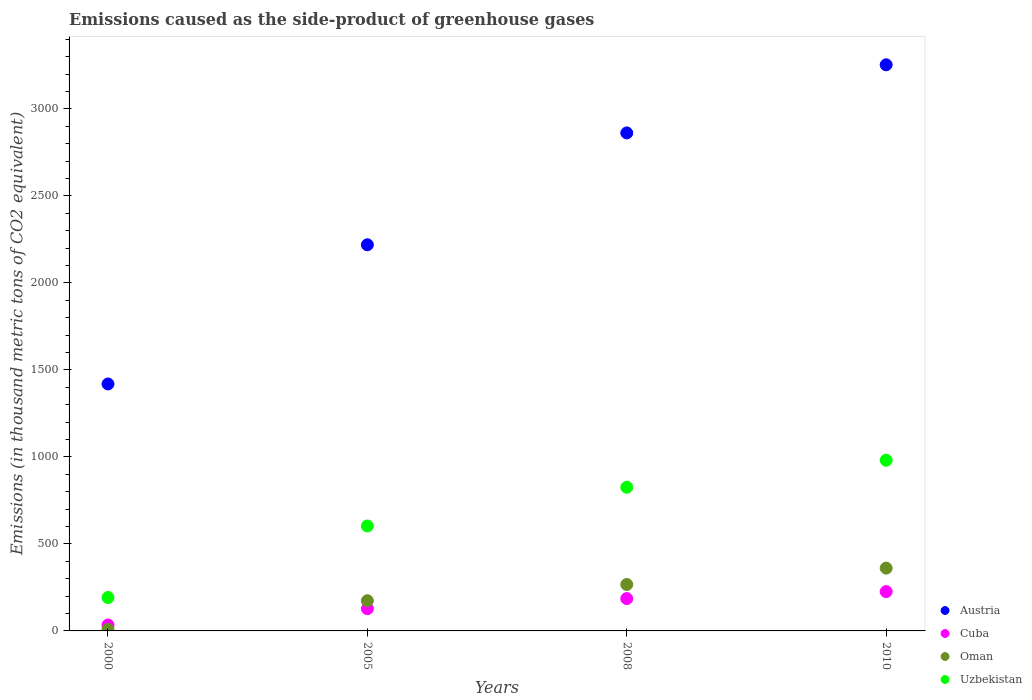How many different coloured dotlines are there?
Provide a succinct answer. 4. What is the emissions caused as the side-product of greenhouse gases in Austria in 2010?
Offer a very short reply. 3254. Across all years, what is the maximum emissions caused as the side-product of greenhouse gases in Austria?
Ensure brevity in your answer.  3254. Across all years, what is the minimum emissions caused as the side-product of greenhouse gases in Cuba?
Offer a terse response. 34.2. In which year was the emissions caused as the side-product of greenhouse gases in Austria maximum?
Offer a very short reply. 2010. What is the total emissions caused as the side-product of greenhouse gases in Oman in the graph?
Provide a short and direct response. 810.1. What is the difference between the emissions caused as the side-product of greenhouse gases in Uzbekistan in 2008 and that in 2010?
Give a very brief answer. -155.4. What is the difference between the emissions caused as the side-product of greenhouse gases in Uzbekistan in 2000 and the emissions caused as the side-product of greenhouse gases in Cuba in 2010?
Give a very brief answer. -34. What is the average emissions caused as the side-product of greenhouse gases in Austria per year?
Ensure brevity in your answer.  2438.85. In the year 2008, what is the difference between the emissions caused as the side-product of greenhouse gases in Cuba and emissions caused as the side-product of greenhouse gases in Oman?
Offer a very short reply. -81. In how many years, is the emissions caused as the side-product of greenhouse gases in Cuba greater than 300 thousand metric tons?
Make the answer very short. 0. What is the ratio of the emissions caused as the side-product of greenhouse gases in Cuba in 2008 to that in 2010?
Offer a very short reply. 0.82. What is the difference between the highest and the second highest emissions caused as the side-product of greenhouse gases in Cuba?
Your response must be concise. 40.1. What is the difference between the highest and the lowest emissions caused as the side-product of greenhouse gases in Austria?
Keep it short and to the point. 1834.5. Is it the case that in every year, the sum of the emissions caused as the side-product of greenhouse gases in Oman and emissions caused as the side-product of greenhouse gases in Uzbekistan  is greater than the emissions caused as the side-product of greenhouse gases in Austria?
Ensure brevity in your answer.  No. Is the emissions caused as the side-product of greenhouse gases in Austria strictly greater than the emissions caused as the side-product of greenhouse gases in Cuba over the years?
Keep it short and to the point. Yes. How many dotlines are there?
Offer a terse response. 4. What is the difference between two consecutive major ticks on the Y-axis?
Provide a succinct answer. 500. Are the values on the major ticks of Y-axis written in scientific E-notation?
Give a very brief answer. No. Does the graph contain grids?
Provide a succinct answer. No. Where does the legend appear in the graph?
Keep it short and to the point. Bottom right. How many legend labels are there?
Your answer should be very brief. 4. What is the title of the graph?
Ensure brevity in your answer.  Emissions caused as the side-product of greenhouse gases. What is the label or title of the X-axis?
Make the answer very short. Years. What is the label or title of the Y-axis?
Your answer should be very brief. Emissions (in thousand metric tons of CO2 equivalent). What is the Emissions (in thousand metric tons of CO2 equivalent) of Austria in 2000?
Your answer should be compact. 1419.5. What is the Emissions (in thousand metric tons of CO2 equivalent) in Cuba in 2000?
Keep it short and to the point. 34.2. What is the Emissions (in thousand metric tons of CO2 equivalent) in Uzbekistan in 2000?
Give a very brief answer. 192. What is the Emissions (in thousand metric tons of CO2 equivalent) in Austria in 2005?
Give a very brief answer. 2219.5. What is the Emissions (in thousand metric tons of CO2 equivalent) of Cuba in 2005?
Your response must be concise. 127.8. What is the Emissions (in thousand metric tons of CO2 equivalent) of Oman in 2005?
Your response must be concise. 173.6. What is the Emissions (in thousand metric tons of CO2 equivalent) in Uzbekistan in 2005?
Ensure brevity in your answer.  603.2. What is the Emissions (in thousand metric tons of CO2 equivalent) in Austria in 2008?
Ensure brevity in your answer.  2862.4. What is the Emissions (in thousand metric tons of CO2 equivalent) of Cuba in 2008?
Provide a succinct answer. 185.9. What is the Emissions (in thousand metric tons of CO2 equivalent) of Oman in 2008?
Keep it short and to the point. 266.9. What is the Emissions (in thousand metric tons of CO2 equivalent) in Uzbekistan in 2008?
Provide a short and direct response. 825.6. What is the Emissions (in thousand metric tons of CO2 equivalent) in Austria in 2010?
Keep it short and to the point. 3254. What is the Emissions (in thousand metric tons of CO2 equivalent) in Cuba in 2010?
Your response must be concise. 226. What is the Emissions (in thousand metric tons of CO2 equivalent) in Oman in 2010?
Ensure brevity in your answer.  361. What is the Emissions (in thousand metric tons of CO2 equivalent) in Uzbekistan in 2010?
Your answer should be very brief. 981. Across all years, what is the maximum Emissions (in thousand metric tons of CO2 equivalent) of Austria?
Offer a terse response. 3254. Across all years, what is the maximum Emissions (in thousand metric tons of CO2 equivalent) of Cuba?
Offer a very short reply. 226. Across all years, what is the maximum Emissions (in thousand metric tons of CO2 equivalent) in Oman?
Keep it short and to the point. 361. Across all years, what is the maximum Emissions (in thousand metric tons of CO2 equivalent) in Uzbekistan?
Keep it short and to the point. 981. Across all years, what is the minimum Emissions (in thousand metric tons of CO2 equivalent) of Austria?
Your answer should be very brief. 1419.5. Across all years, what is the minimum Emissions (in thousand metric tons of CO2 equivalent) in Cuba?
Your answer should be compact. 34.2. Across all years, what is the minimum Emissions (in thousand metric tons of CO2 equivalent) of Uzbekistan?
Offer a terse response. 192. What is the total Emissions (in thousand metric tons of CO2 equivalent) of Austria in the graph?
Offer a very short reply. 9755.4. What is the total Emissions (in thousand metric tons of CO2 equivalent) of Cuba in the graph?
Make the answer very short. 573.9. What is the total Emissions (in thousand metric tons of CO2 equivalent) in Oman in the graph?
Provide a succinct answer. 810.1. What is the total Emissions (in thousand metric tons of CO2 equivalent) of Uzbekistan in the graph?
Provide a succinct answer. 2601.8. What is the difference between the Emissions (in thousand metric tons of CO2 equivalent) in Austria in 2000 and that in 2005?
Make the answer very short. -800. What is the difference between the Emissions (in thousand metric tons of CO2 equivalent) in Cuba in 2000 and that in 2005?
Offer a very short reply. -93.6. What is the difference between the Emissions (in thousand metric tons of CO2 equivalent) of Oman in 2000 and that in 2005?
Ensure brevity in your answer.  -165. What is the difference between the Emissions (in thousand metric tons of CO2 equivalent) in Uzbekistan in 2000 and that in 2005?
Offer a very short reply. -411.2. What is the difference between the Emissions (in thousand metric tons of CO2 equivalent) in Austria in 2000 and that in 2008?
Ensure brevity in your answer.  -1442.9. What is the difference between the Emissions (in thousand metric tons of CO2 equivalent) of Cuba in 2000 and that in 2008?
Your answer should be compact. -151.7. What is the difference between the Emissions (in thousand metric tons of CO2 equivalent) in Oman in 2000 and that in 2008?
Provide a short and direct response. -258.3. What is the difference between the Emissions (in thousand metric tons of CO2 equivalent) in Uzbekistan in 2000 and that in 2008?
Offer a terse response. -633.6. What is the difference between the Emissions (in thousand metric tons of CO2 equivalent) in Austria in 2000 and that in 2010?
Provide a succinct answer. -1834.5. What is the difference between the Emissions (in thousand metric tons of CO2 equivalent) in Cuba in 2000 and that in 2010?
Ensure brevity in your answer.  -191.8. What is the difference between the Emissions (in thousand metric tons of CO2 equivalent) in Oman in 2000 and that in 2010?
Offer a very short reply. -352.4. What is the difference between the Emissions (in thousand metric tons of CO2 equivalent) in Uzbekistan in 2000 and that in 2010?
Keep it short and to the point. -789. What is the difference between the Emissions (in thousand metric tons of CO2 equivalent) in Austria in 2005 and that in 2008?
Your answer should be compact. -642.9. What is the difference between the Emissions (in thousand metric tons of CO2 equivalent) in Cuba in 2005 and that in 2008?
Your response must be concise. -58.1. What is the difference between the Emissions (in thousand metric tons of CO2 equivalent) in Oman in 2005 and that in 2008?
Keep it short and to the point. -93.3. What is the difference between the Emissions (in thousand metric tons of CO2 equivalent) in Uzbekistan in 2005 and that in 2008?
Provide a short and direct response. -222.4. What is the difference between the Emissions (in thousand metric tons of CO2 equivalent) in Austria in 2005 and that in 2010?
Provide a short and direct response. -1034.5. What is the difference between the Emissions (in thousand metric tons of CO2 equivalent) of Cuba in 2005 and that in 2010?
Provide a succinct answer. -98.2. What is the difference between the Emissions (in thousand metric tons of CO2 equivalent) of Oman in 2005 and that in 2010?
Make the answer very short. -187.4. What is the difference between the Emissions (in thousand metric tons of CO2 equivalent) in Uzbekistan in 2005 and that in 2010?
Your response must be concise. -377.8. What is the difference between the Emissions (in thousand metric tons of CO2 equivalent) of Austria in 2008 and that in 2010?
Ensure brevity in your answer.  -391.6. What is the difference between the Emissions (in thousand metric tons of CO2 equivalent) of Cuba in 2008 and that in 2010?
Your answer should be very brief. -40.1. What is the difference between the Emissions (in thousand metric tons of CO2 equivalent) in Oman in 2008 and that in 2010?
Provide a succinct answer. -94.1. What is the difference between the Emissions (in thousand metric tons of CO2 equivalent) of Uzbekistan in 2008 and that in 2010?
Provide a succinct answer. -155.4. What is the difference between the Emissions (in thousand metric tons of CO2 equivalent) of Austria in 2000 and the Emissions (in thousand metric tons of CO2 equivalent) of Cuba in 2005?
Offer a terse response. 1291.7. What is the difference between the Emissions (in thousand metric tons of CO2 equivalent) of Austria in 2000 and the Emissions (in thousand metric tons of CO2 equivalent) of Oman in 2005?
Keep it short and to the point. 1245.9. What is the difference between the Emissions (in thousand metric tons of CO2 equivalent) in Austria in 2000 and the Emissions (in thousand metric tons of CO2 equivalent) in Uzbekistan in 2005?
Provide a succinct answer. 816.3. What is the difference between the Emissions (in thousand metric tons of CO2 equivalent) of Cuba in 2000 and the Emissions (in thousand metric tons of CO2 equivalent) of Oman in 2005?
Keep it short and to the point. -139.4. What is the difference between the Emissions (in thousand metric tons of CO2 equivalent) in Cuba in 2000 and the Emissions (in thousand metric tons of CO2 equivalent) in Uzbekistan in 2005?
Provide a succinct answer. -569. What is the difference between the Emissions (in thousand metric tons of CO2 equivalent) of Oman in 2000 and the Emissions (in thousand metric tons of CO2 equivalent) of Uzbekistan in 2005?
Offer a terse response. -594.6. What is the difference between the Emissions (in thousand metric tons of CO2 equivalent) of Austria in 2000 and the Emissions (in thousand metric tons of CO2 equivalent) of Cuba in 2008?
Give a very brief answer. 1233.6. What is the difference between the Emissions (in thousand metric tons of CO2 equivalent) of Austria in 2000 and the Emissions (in thousand metric tons of CO2 equivalent) of Oman in 2008?
Give a very brief answer. 1152.6. What is the difference between the Emissions (in thousand metric tons of CO2 equivalent) of Austria in 2000 and the Emissions (in thousand metric tons of CO2 equivalent) of Uzbekistan in 2008?
Offer a terse response. 593.9. What is the difference between the Emissions (in thousand metric tons of CO2 equivalent) of Cuba in 2000 and the Emissions (in thousand metric tons of CO2 equivalent) of Oman in 2008?
Your answer should be compact. -232.7. What is the difference between the Emissions (in thousand metric tons of CO2 equivalent) in Cuba in 2000 and the Emissions (in thousand metric tons of CO2 equivalent) in Uzbekistan in 2008?
Provide a short and direct response. -791.4. What is the difference between the Emissions (in thousand metric tons of CO2 equivalent) in Oman in 2000 and the Emissions (in thousand metric tons of CO2 equivalent) in Uzbekistan in 2008?
Ensure brevity in your answer.  -817. What is the difference between the Emissions (in thousand metric tons of CO2 equivalent) in Austria in 2000 and the Emissions (in thousand metric tons of CO2 equivalent) in Cuba in 2010?
Make the answer very short. 1193.5. What is the difference between the Emissions (in thousand metric tons of CO2 equivalent) of Austria in 2000 and the Emissions (in thousand metric tons of CO2 equivalent) of Oman in 2010?
Your answer should be very brief. 1058.5. What is the difference between the Emissions (in thousand metric tons of CO2 equivalent) of Austria in 2000 and the Emissions (in thousand metric tons of CO2 equivalent) of Uzbekistan in 2010?
Keep it short and to the point. 438.5. What is the difference between the Emissions (in thousand metric tons of CO2 equivalent) of Cuba in 2000 and the Emissions (in thousand metric tons of CO2 equivalent) of Oman in 2010?
Keep it short and to the point. -326.8. What is the difference between the Emissions (in thousand metric tons of CO2 equivalent) in Cuba in 2000 and the Emissions (in thousand metric tons of CO2 equivalent) in Uzbekistan in 2010?
Keep it short and to the point. -946.8. What is the difference between the Emissions (in thousand metric tons of CO2 equivalent) of Oman in 2000 and the Emissions (in thousand metric tons of CO2 equivalent) of Uzbekistan in 2010?
Your response must be concise. -972.4. What is the difference between the Emissions (in thousand metric tons of CO2 equivalent) in Austria in 2005 and the Emissions (in thousand metric tons of CO2 equivalent) in Cuba in 2008?
Offer a terse response. 2033.6. What is the difference between the Emissions (in thousand metric tons of CO2 equivalent) of Austria in 2005 and the Emissions (in thousand metric tons of CO2 equivalent) of Oman in 2008?
Keep it short and to the point. 1952.6. What is the difference between the Emissions (in thousand metric tons of CO2 equivalent) in Austria in 2005 and the Emissions (in thousand metric tons of CO2 equivalent) in Uzbekistan in 2008?
Offer a very short reply. 1393.9. What is the difference between the Emissions (in thousand metric tons of CO2 equivalent) of Cuba in 2005 and the Emissions (in thousand metric tons of CO2 equivalent) of Oman in 2008?
Provide a short and direct response. -139.1. What is the difference between the Emissions (in thousand metric tons of CO2 equivalent) in Cuba in 2005 and the Emissions (in thousand metric tons of CO2 equivalent) in Uzbekistan in 2008?
Your response must be concise. -697.8. What is the difference between the Emissions (in thousand metric tons of CO2 equivalent) in Oman in 2005 and the Emissions (in thousand metric tons of CO2 equivalent) in Uzbekistan in 2008?
Provide a succinct answer. -652. What is the difference between the Emissions (in thousand metric tons of CO2 equivalent) in Austria in 2005 and the Emissions (in thousand metric tons of CO2 equivalent) in Cuba in 2010?
Offer a terse response. 1993.5. What is the difference between the Emissions (in thousand metric tons of CO2 equivalent) of Austria in 2005 and the Emissions (in thousand metric tons of CO2 equivalent) of Oman in 2010?
Provide a short and direct response. 1858.5. What is the difference between the Emissions (in thousand metric tons of CO2 equivalent) in Austria in 2005 and the Emissions (in thousand metric tons of CO2 equivalent) in Uzbekistan in 2010?
Offer a terse response. 1238.5. What is the difference between the Emissions (in thousand metric tons of CO2 equivalent) of Cuba in 2005 and the Emissions (in thousand metric tons of CO2 equivalent) of Oman in 2010?
Offer a terse response. -233.2. What is the difference between the Emissions (in thousand metric tons of CO2 equivalent) in Cuba in 2005 and the Emissions (in thousand metric tons of CO2 equivalent) in Uzbekistan in 2010?
Provide a succinct answer. -853.2. What is the difference between the Emissions (in thousand metric tons of CO2 equivalent) in Oman in 2005 and the Emissions (in thousand metric tons of CO2 equivalent) in Uzbekistan in 2010?
Give a very brief answer. -807.4. What is the difference between the Emissions (in thousand metric tons of CO2 equivalent) in Austria in 2008 and the Emissions (in thousand metric tons of CO2 equivalent) in Cuba in 2010?
Your answer should be very brief. 2636.4. What is the difference between the Emissions (in thousand metric tons of CO2 equivalent) in Austria in 2008 and the Emissions (in thousand metric tons of CO2 equivalent) in Oman in 2010?
Your response must be concise. 2501.4. What is the difference between the Emissions (in thousand metric tons of CO2 equivalent) in Austria in 2008 and the Emissions (in thousand metric tons of CO2 equivalent) in Uzbekistan in 2010?
Keep it short and to the point. 1881.4. What is the difference between the Emissions (in thousand metric tons of CO2 equivalent) of Cuba in 2008 and the Emissions (in thousand metric tons of CO2 equivalent) of Oman in 2010?
Make the answer very short. -175.1. What is the difference between the Emissions (in thousand metric tons of CO2 equivalent) in Cuba in 2008 and the Emissions (in thousand metric tons of CO2 equivalent) in Uzbekistan in 2010?
Your response must be concise. -795.1. What is the difference between the Emissions (in thousand metric tons of CO2 equivalent) of Oman in 2008 and the Emissions (in thousand metric tons of CO2 equivalent) of Uzbekistan in 2010?
Make the answer very short. -714.1. What is the average Emissions (in thousand metric tons of CO2 equivalent) of Austria per year?
Your answer should be compact. 2438.85. What is the average Emissions (in thousand metric tons of CO2 equivalent) of Cuba per year?
Your answer should be very brief. 143.47. What is the average Emissions (in thousand metric tons of CO2 equivalent) of Oman per year?
Keep it short and to the point. 202.53. What is the average Emissions (in thousand metric tons of CO2 equivalent) of Uzbekistan per year?
Offer a very short reply. 650.45. In the year 2000, what is the difference between the Emissions (in thousand metric tons of CO2 equivalent) of Austria and Emissions (in thousand metric tons of CO2 equivalent) of Cuba?
Your answer should be very brief. 1385.3. In the year 2000, what is the difference between the Emissions (in thousand metric tons of CO2 equivalent) in Austria and Emissions (in thousand metric tons of CO2 equivalent) in Oman?
Provide a succinct answer. 1410.9. In the year 2000, what is the difference between the Emissions (in thousand metric tons of CO2 equivalent) in Austria and Emissions (in thousand metric tons of CO2 equivalent) in Uzbekistan?
Ensure brevity in your answer.  1227.5. In the year 2000, what is the difference between the Emissions (in thousand metric tons of CO2 equivalent) in Cuba and Emissions (in thousand metric tons of CO2 equivalent) in Oman?
Keep it short and to the point. 25.6. In the year 2000, what is the difference between the Emissions (in thousand metric tons of CO2 equivalent) in Cuba and Emissions (in thousand metric tons of CO2 equivalent) in Uzbekistan?
Give a very brief answer. -157.8. In the year 2000, what is the difference between the Emissions (in thousand metric tons of CO2 equivalent) in Oman and Emissions (in thousand metric tons of CO2 equivalent) in Uzbekistan?
Your response must be concise. -183.4. In the year 2005, what is the difference between the Emissions (in thousand metric tons of CO2 equivalent) of Austria and Emissions (in thousand metric tons of CO2 equivalent) of Cuba?
Your response must be concise. 2091.7. In the year 2005, what is the difference between the Emissions (in thousand metric tons of CO2 equivalent) of Austria and Emissions (in thousand metric tons of CO2 equivalent) of Oman?
Provide a succinct answer. 2045.9. In the year 2005, what is the difference between the Emissions (in thousand metric tons of CO2 equivalent) in Austria and Emissions (in thousand metric tons of CO2 equivalent) in Uzbekistan?
Offer a terse response. 1616.3. In the year 2005, what is the difference between the Emissions (in thousand metric tons of CO2 equivalent) of Cuba and Emissions (in thousand metric tons of CO2 equivalent) of Oman?
Ensure brevity in your answer.  -45.8. In the year 2005, what is the difference between the Emissions (in thousand metric tons of CO2 equivalent) in Cuba and Emissions (in thousand metric tons of CO2 equivalent) in Uzbekistan?
Keep it short and to the point. -475.4. In the year 2005, what is the difference between the Emissions (in thousand metric tons of CO2 equivalent) of Oman and Emissions (in thousand metric tons of CO2 equivalent) of Uzbekistan?
Ensure brevity in your answer.  -429.6. In the year 2008, what is the difference between the Emissions (in thousand metric tons of CO2 equivalent) of Austria and Emissions (in thousand metric tons of CO2 equivalent) of Cuba?
Offer a terse response. 2676.5. In the year 2008, what is the difference between the Emissions (in thousand metric tons of CO2 equivalent) in Austria and Emissions (in thousand metric tons of CO2 equivalent) in Oman?
Offer a very short reply. 2595.5. In the year 2008, what is the difference between the Emissions (in thousand metric tons of CO2 equivalent) in Austria and Emissions (in thousand metric tons of CO2 equivalent) in Uzbekistan?
Your answer should be compact. 2036.8. In the year 2008, what is the difference between the Emissions (in thousand metric tons of CO2 equivalent) of Cuba and Emissions (in thousand metric tons of CO2 equivalent) of Oman?
Your response must be concise. -81. In the year 2008, what is the difference between the Emissions (in thousand metric tons of CO2 equivalent) in Cuba and Emissions (in thousand metric tons of CO2 equivalent) in Uzbekistan?
Offer a very short reply. -639.7. In the year 2008, what is the difference between the Emissions (in thousand metric tons of CO2 equivalent) in Oman and Emissions (in thousand metric tons of CO2 equivalent) in Uzbekistan?
Ensure brevity in your answer.  -558.7. In the year 2010, what is the difference between the Emissions (in thousand metric tons of CO2 equivalent) in Austria and Emissions (in thousand metric tons of CO2 equivalent) in Cuba?
Your answer should be compact. 3028. In the year 2010, what is the difference between the Emissions (in thousand metric tons of CO2 equivalent) of Austria and Emissions (in thousand metric tons of CO2 equivalent) of Oman?
Ensure brevity in your answer.  2893. In the year 2010, what is the difference between the Emissions (in thousand metric tons of CO2 equivalent) in Austria and Emissions (in thousand metric tons of CO2 equivalent) in Uzbekistan?
Offer a very short reply. 2273. In the year 2010, what is the difference between the Emissions (in thousand metric tons of CO2 equivalent) in Cuba and Emissions (in thousand metric tons of CO2 equivalent) in Oman?
Provide a short and direct response. -135. In the year 2010, what is the difference between the Emissions (in thousand metric tons of CO2 equivalent) of Cuba and Emissions (in thousand metric tons of CO2 equivalent) of Uzbekistan?
Give a very brief answer. -755. In the year 2010, what is the difference between the Emissions (in thousand metric tons of CO2 equivalent) in Oman and Emissions (in thousand metric tons of CO2 equivalent) in Uzbekistan?
Make the answer very short. -620. What is the ratio of the Emissions (in thousand metric tons of CO2 equivalent) of Austria in 2000 to that in 2005?
Offer a very short reply. 0.64. What is the ratio of the Emissions (in thousand metric tons of CO2 equivalent) of Cuba in 2000 to that in 2005?
Ensure brevity in your answer.  0.27. What is the ratio of the Emissions (in thousand metric tons of CO2 equivalent) in Oman in 2000 to that in 2005?
Ensure brevity in your answer.  0.05. What is the ratio of the Emissions (in thousand metric tons of CO2 equivalent) of Uzbekistan in 2000 to that in 2005?
Provide a short and direct response. 0.32. What is the ratio of the Emissions (in thousand metric tons of CO2 equivalent) in Austria in 2000 to that in 2008?
Give a very brief answer. 0.5. What is the ratio of the Emissions (in thousand metric tons of CO2 equivalent) in Cuba in 2000 to that in 2008?
Your answer should be very brief. 0.18. What is the ratio of the Emissions (in thousand metric tons of CO2 equivalent) in Oman in 2000 to that in 2008?
Give a very brief answer. 0.03. What is the ratio of the Emissions (in thousand metric tons of CO2 equivalent) of Uzbekistan in 2000 to that in 2008?
Give a very brief answer. 0.23. What is the ratio of the Emissions (in thousand metric tons of CO2 equivalent) of Austria in 2000 to that in 2010?
Offer a terse response. 0.44. What is the ratio of the Emissions (in thousand metric tons of CO2 equivalent) of Cuba in 2000 to that in 2010?
Make the answer very short. 0.15. What is the ratio of the Emissions (in thousand metric tons of CO2 equivalent) of Oman in 2000 to that in 2010?
Give a very brief answer. 0.02. What is the ratio of the Emissions (in thousand metric tons of CO2 equivalent) in Uzbekistan in 2000 to that in 2010?
Your answer should be compact. 0.2. What is the ratio of the Emissions (in thousand metric tons of CO2 equivalent) of Austria in 2005 to that in 2008?
Offer a very short reply. 0.78. What is the ratio of the Emissions (in thousand metric tons of CO2 equivalent) in Cuba in 2005 to that in 2008?
Offer a terse response. 0.69. What is the ratio of the Emissions (in thousand metric tons of CO2 equivalent) in Oman in 2005 to that in 2008?
Offer a very short reply. 0.65. What is the ratio of the Emissions (in thousand metric tons of CO2 equivalent) of Uzbekistan in 2005 to that in 2008?
Your response must be concise. 0.73. What is the ratio of the Emissions (in thousand metric tons of CO2 equivalent) in Austria in 2005 to that in 2010?
Offer a terse response. 0.68. What is the ratio of the Emissions (in thousand metric tons of CO2 equivalent) in Cuba in 2005 to that in 2010?
Provide a short and direct response. 0.57. What is the ratio of the Emissions (in thousand metric tons of CO2 equivalent) in Oman in 2005 to that in 2010?
Offer a terse response. 0.48. What is the ratio of the Emissions (in thousand metric tons of CO2 equivalent) of Uzbekistan in 2005 to that in 2010?
Make the answer very short. 0.61. What is the ratio of the Emissions (in thousand metric tons of CO2 equivalent) of Austria in 2008 to that in 2010?
Your answer should be compact. 0.88. What is the ratio of the Emissions (in thousand metric tons of CO2 equivalent) in Cuba in 2008 to that in 2010?
Offer a very short reply. 0.82. What is the ratio of the Emissions (in thousand metric tons of CO2 equivalent) of Oman in 2008 to that in 2010?
Ensure brevity in your answer.  0.74. What is the ratio of the Emissions (in thousand metric tons of CO2 equivalent) of Uzbekistan in 2008 to that in 2010?
Your answer should be very brief. 0.84. What is the difference between the highest and the second highest Emissions (in thousand metric tons of CO2 equivalent) of Austria?
Offer a very short reply. 391.6. What is the difference between the highest and the second highest Emissions (in thousand metric tons of CO2 equivalent) in Cuba?
Offer a terse response. 40.1. What is the difference between the highest and the second highest Emissions (in thousand metric tons of CO2 equivalent) of Oman?
Make the answer very short. 94.1. What is the difference between the highest and the second highest Emissions (in thousand metric tons of CO2 equivalent) of Uzbekistan?
Keep it short and to the point. 155.4. What is the difference between the highest and the lowest Emissions (in thousand metric tons of CO2 equivalent) in Austria?
Make the answer very short. 1834.5. What is the difference between the highest and the lowest Emissions (in thousand metric tons of CO2 equivalent) in Cuba?
Provide a short and direct response. 191.8. What is the difference between the highest and the lowest Emissions (in thousand metric tons of CO2 equivalent) of Oman?
Your answer should be compact. 352.4. What is the difference between the highest and the lowest Emissions (in thousand metric tons of CO2 equivalent) of Uzbekistan?
Provide a succinct answer. 789. 